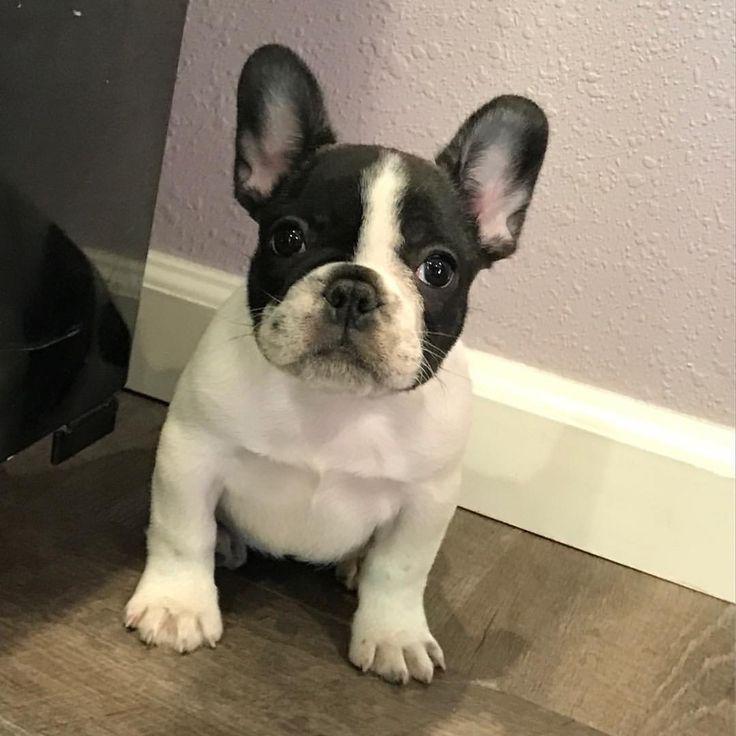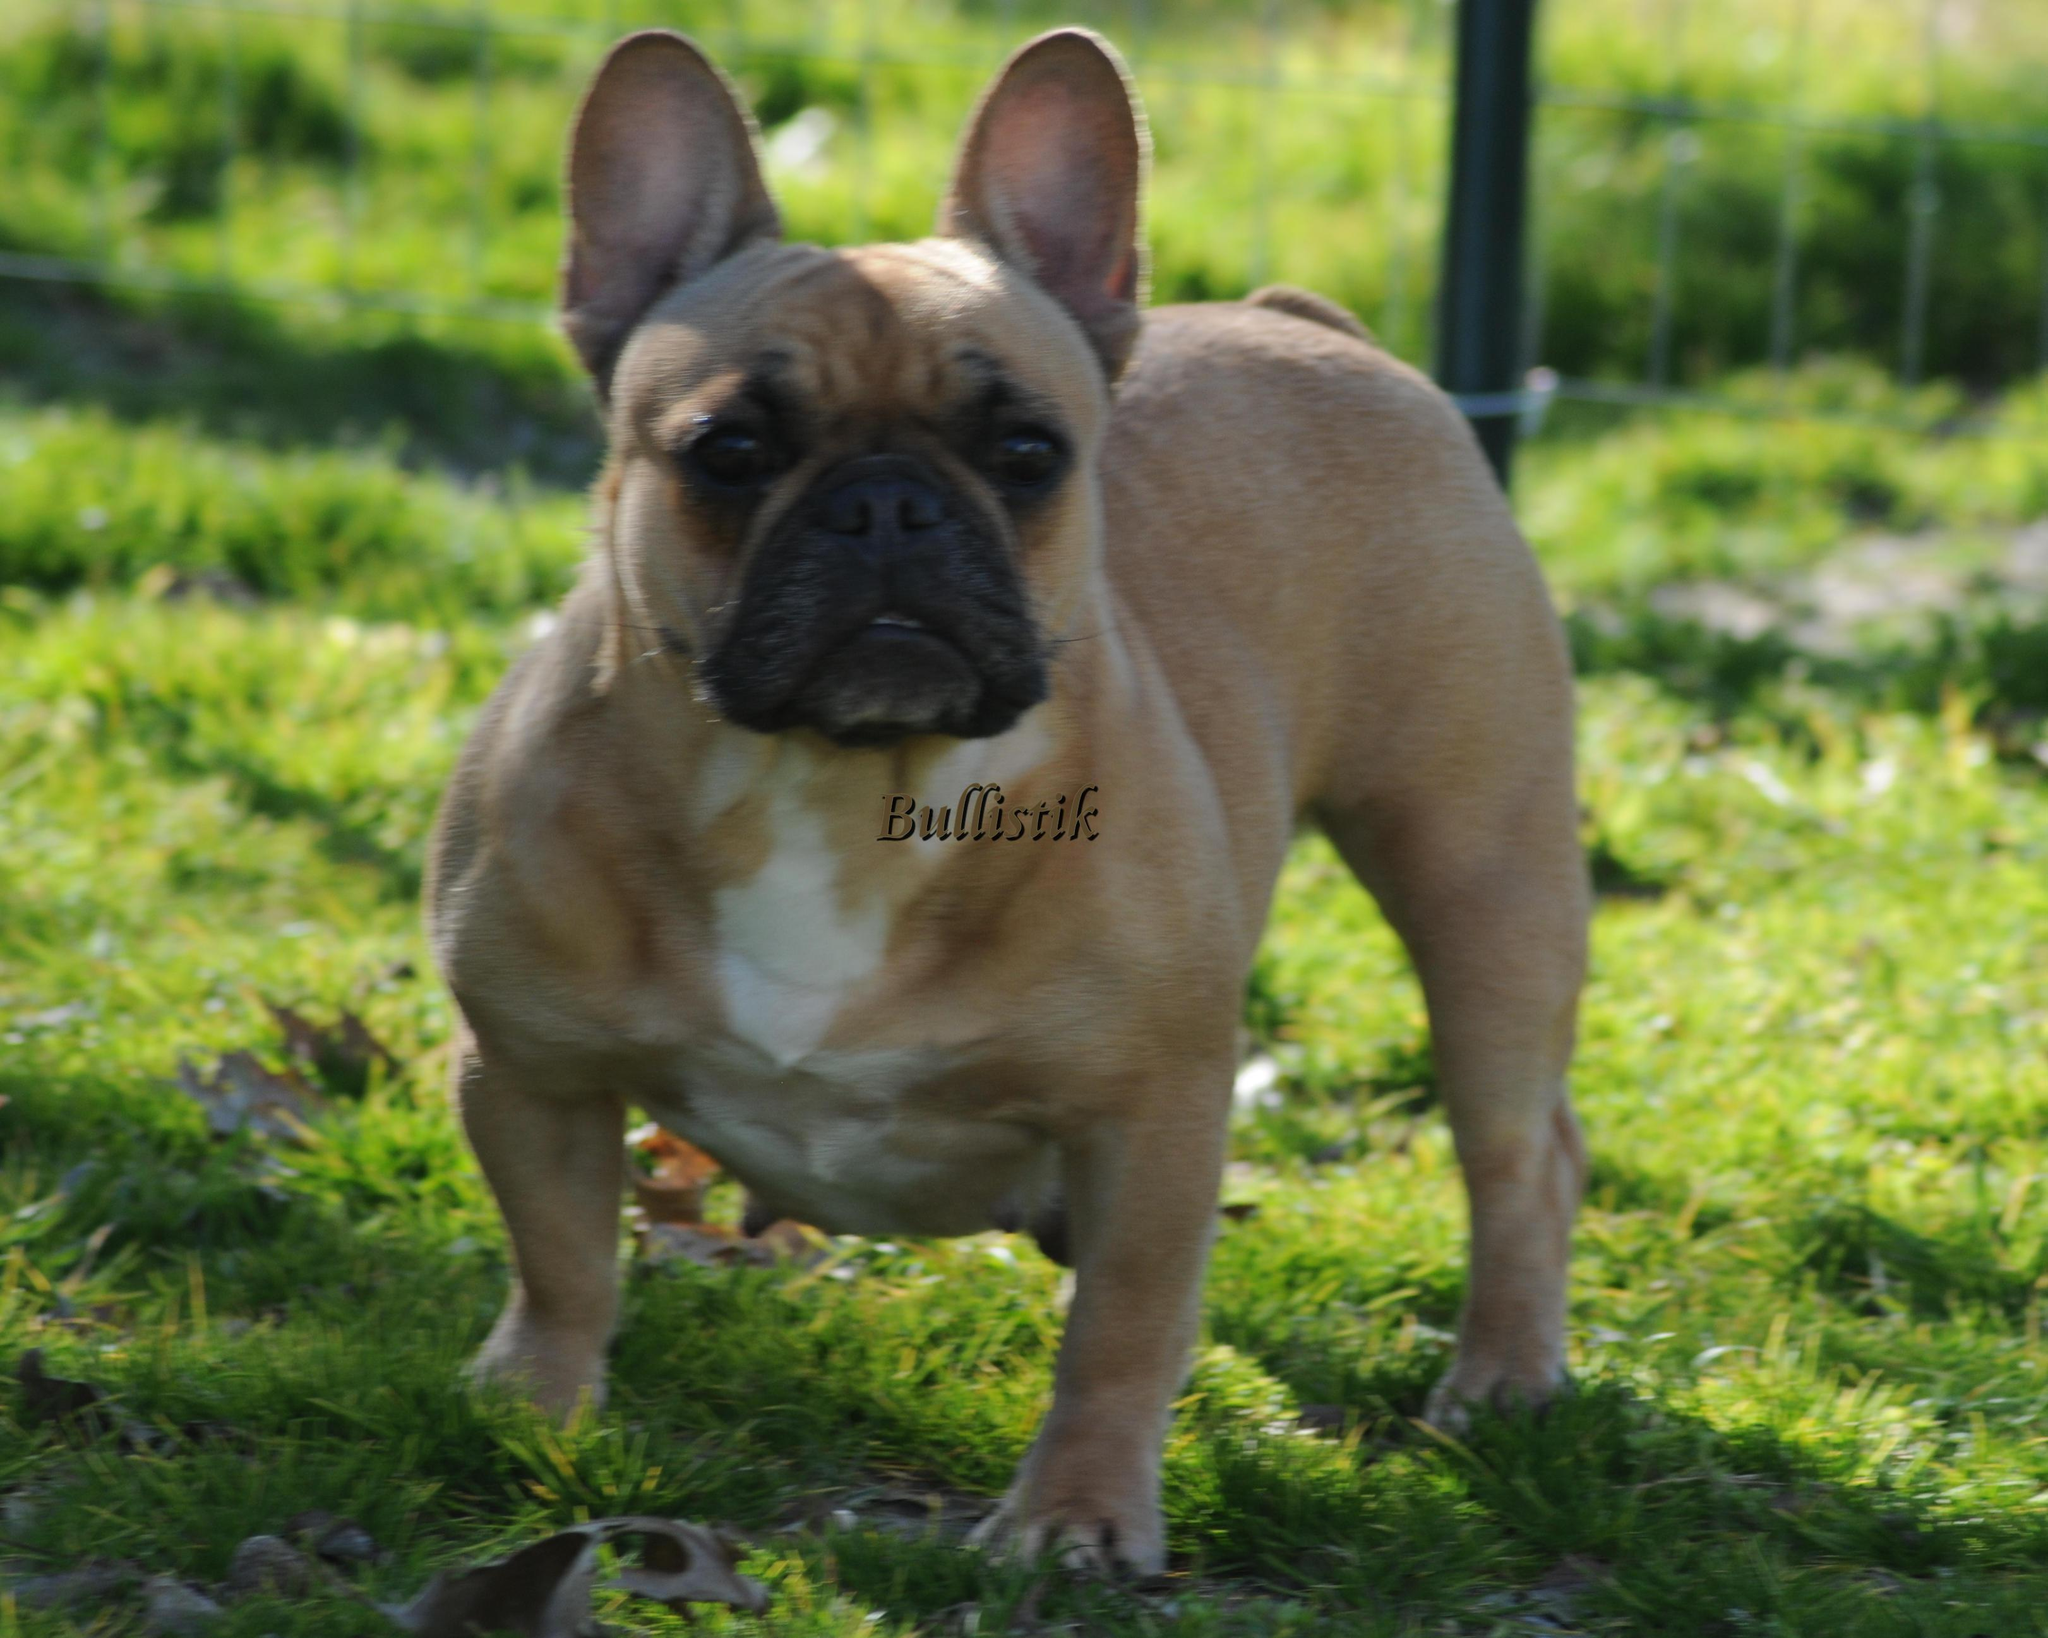The first image is the image on the left, the second image is the image on the right. Analyze the images presented: Is the assertion "One image features exactly two dogs posed close together and facing  forward." valid? Answer yes or no. No. The first image is the image on the left, the second image is the image on the right. For the images shown, is this caption "There are three dogs" true? Answer yes or no. No. 